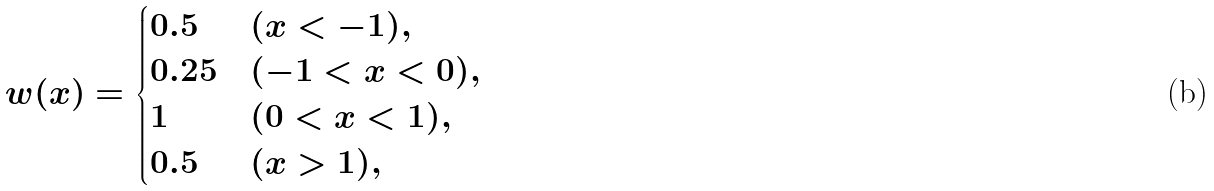<formula> <loc_0><loc_0><loc_500><loc_500>w ( x ) = \begin{cases} 0 . 5 & ( x < - 1 ) , \\ 0 . 2 5 & ( - 1 < x < 0 ) , \\ 1 & ( 0 < x < 1 ) , \\ 0 . 5 & ( x > 1 ) , \end{cases}</formula> 